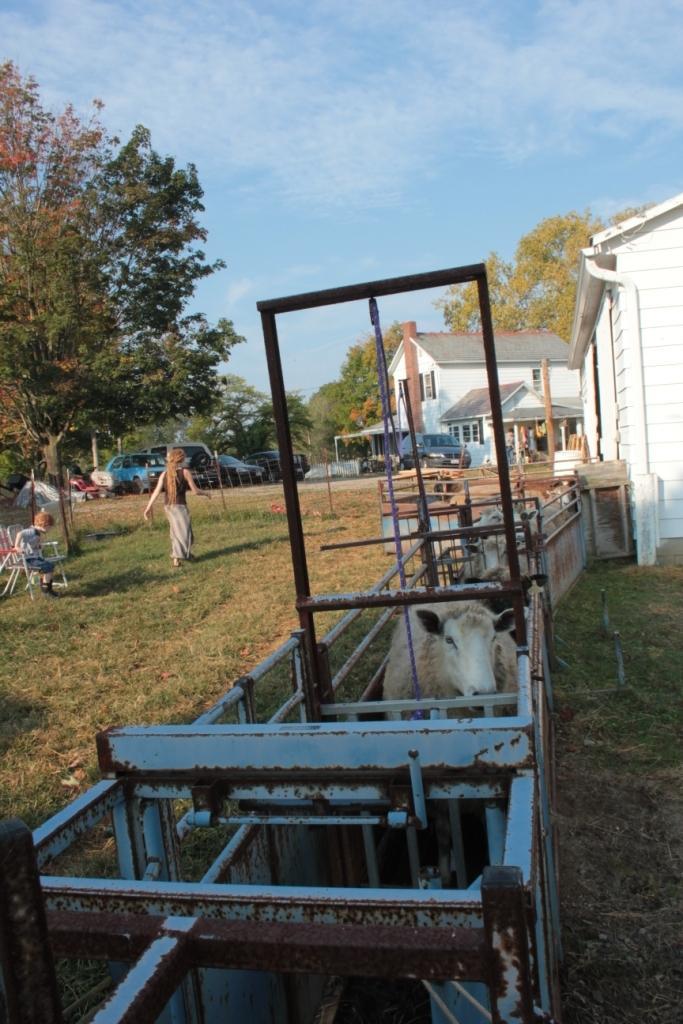Could you give a brief overview of what you see in this image? In this image we can see animals in a metal object. In the background, we can see houses, cars, trees, grassy land, a woman and a boy. At the top of the image, we can see the sky. 